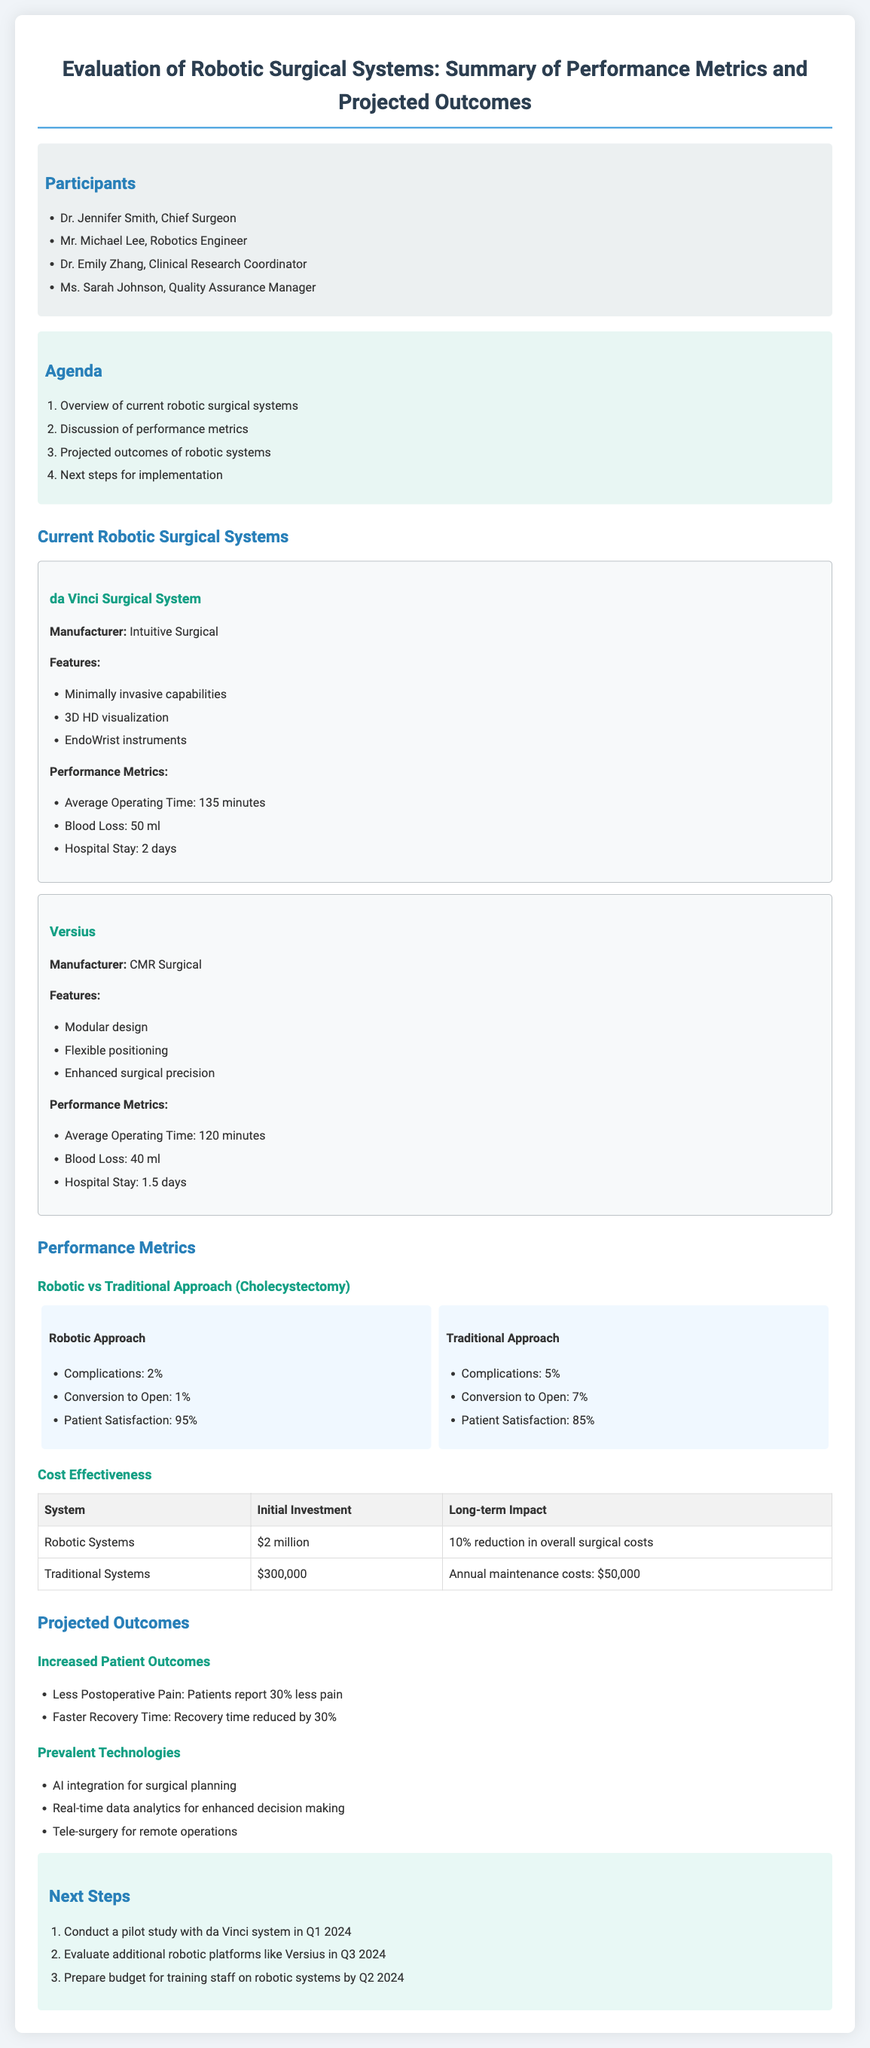What is the name of the first robotic system mentioned? The first robotic system mentioned is the da Vinci Surgical System.
Answer: da Vinci Surgical System Who is the Chief Surgeon participating in the meeting? The Chief Surgeon participating in the meeting is Dr. Jennifer Smith.
Answer: Dr. Jennifer Smith What is the average operating time for the Versius system? The average operating time for the Versius system is 120 minutes.
Answer: 120 minutes What percentage of patients reported satisfaction with the robotic approach in cholecystectomy? 95% of patients reported satisfaction with the robotic approach.
Answer: 95% What is the initial investment cost for robotic systems? The initial investment cost for robotic systems is $2 million.
Answer: $2 million Which robotic system has a blood loss metric of 40 ml? The robotic system with a blood loss metric of 40 ml is Versius.
Answer: Versius How much less postoperative pain do patients report with robotic systems? Patients report 30% less postoperative pain with robotic systems.
Answer: 30% What is the next step planned for Q1 2024? The next step planned for Q1 2024 is to conduct a pilot study with the da Vinci system.
Answer: conduct a pilot study with da Vinci system What are the two prevalent technologies mentioned for robotic systems? The two prevalent technologies mentioned are AI integration for surgical planning and real-time data analytics for enhanced decision making.
Answer: AI integration and real-time data analytics 